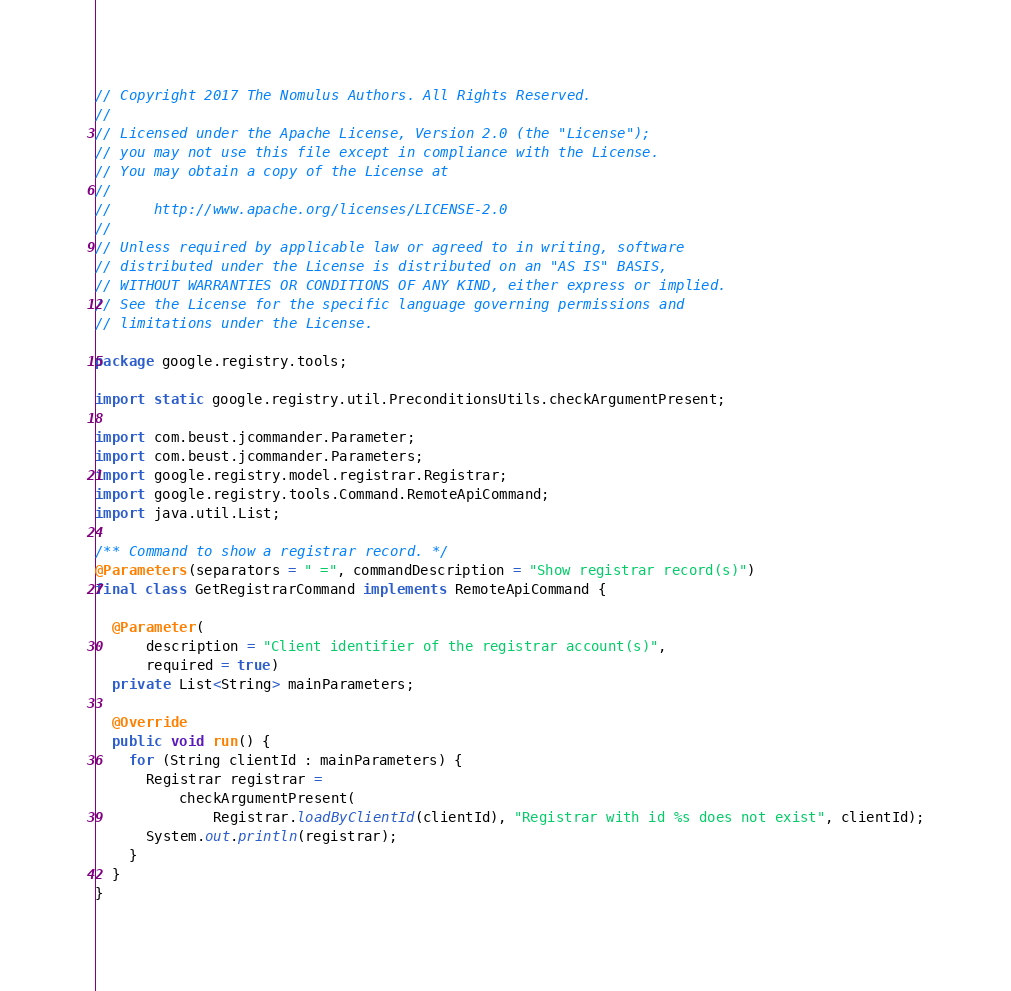Convert code to text. <code><loc_0><loc_0><loc_500><loc_500><_Java_>// Copyright 2017 The Nomulus Authors. All Rights Reserved.
//
// Licensed under the Apache License, Version 2.0 (the "License");
// you may not use this file except in compliance with the License.
// You may obtain a copy of the License at
//
//     http://www.apache.org/licenses/LICENSE-2.0
//
// Unless required by applicable law or agreed to in writing, software
// distributed under the License is distributed on an "AS IS" BASIS,
// WITHOUT WARRANTIES OR CONDITIONS OF ANY KIND, either express or implied.
// See the License for the specific language governing permissions and
// limitations under the License.

package google.registry.tools;

import static google.registry.util.PreconditionsUtils.checkArgumentPresent;

import com.beust.jcommander.Parameter;
import com.beust.jcommander.Parameters;
import google.registry.model.registrar.Registrar;
import google.registry.tools.Command.RemoteApiCommand;
import java.util.List;

/** Command to show a registrar record. */
@Parameters(separators = " =", commandDescription = "Show registrar record(s)")
final class GetRegistrarCommand implements RemoteApiCommand {

  @Parameter(
      description = "Client identifier of the registrar account(s)",
      required = true)
  private List<String> mainParameters;

  @Override
  public void run() {
    for (String clientId : mainParameters) {
      Registrar registrar =
          checkArgumentPresent(
              Registrar.loadByClientId(clientId), "Registrar with id %s does not exist", clientId);
      System.out.println(registrar);
    }
  }
}
</code> 